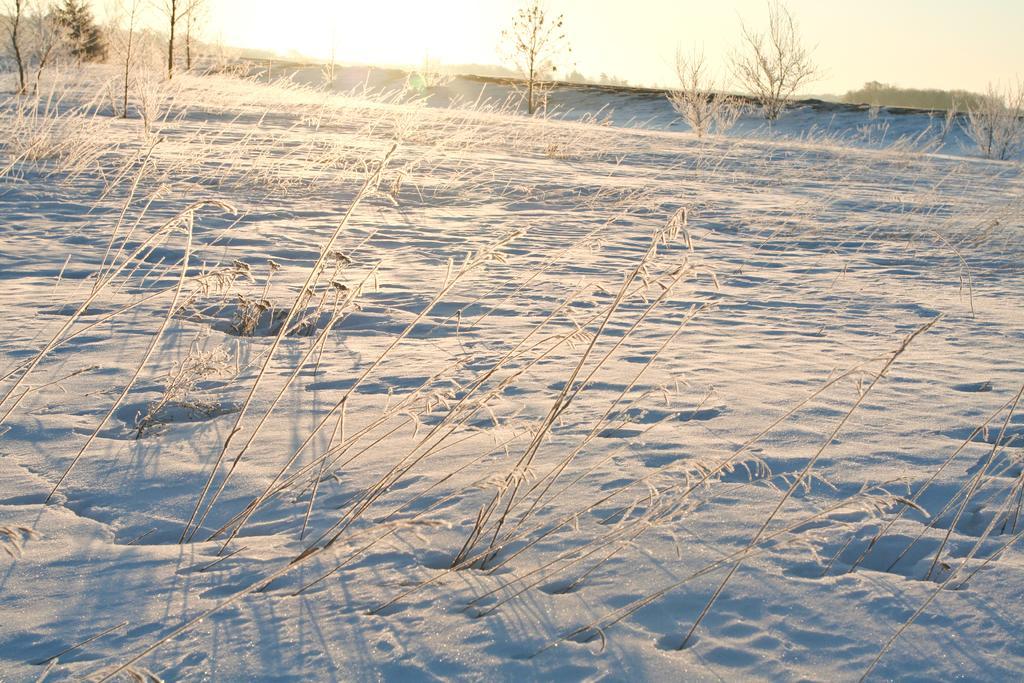Can you describe this image briefly? At the bottom of the picture, we see plants and ice. There are trees in the background. At the top of the picture, we see the sun and it is a sunny day. 